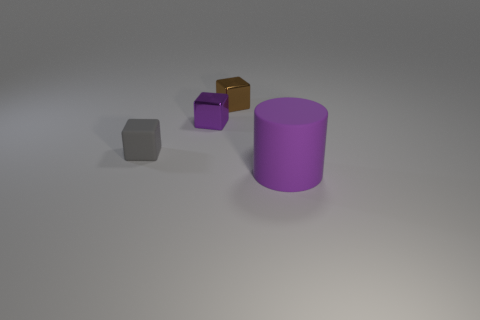Add 1 gray blocks. How many objects exist? 5 Subtract all cylinders. How many objects are left? 3 Subtract all tiny gray rubber blocks. Subtract all gray blocks. How many objects are left? 2 Add 4 rubber blocks. How many rubber blocks are left? 5 Add 2 large gray shiny things. How many large gray shiny things exist? 2 Subtract 0 blue cylinders. How many objects are left? 4 